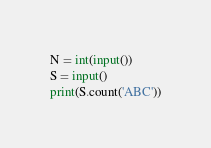Convert code to text. <code><loc_0><loc_0><loc_500><loc_500><_Python_>N = int(input())
S = input()
print(S.count('ABC'))</code> 